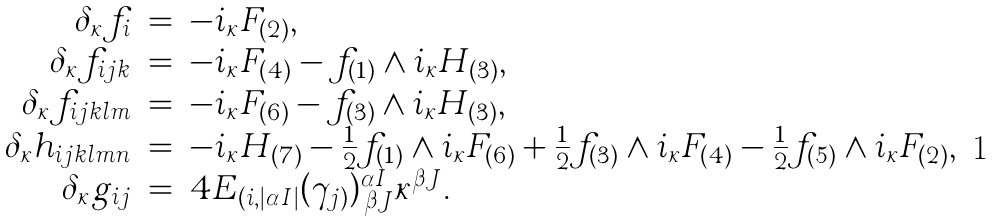Convert formula to latex. <formula><loc_0><loc_0><loc_500><loc_500>\begin{array} { r c l } \delta _ { \kappa } f _ { i } & = & - i _ { \kappa } F _ { ( 2 ) } , \\ \delta _ { \kappa } f _ { i j k } & = & - i _ { \kappa } F _ { ( 4 ) } - f _ { ( 1 ) } \wedge i _ { \kappa } H _ { ( 3 ) } , \\ \delta _ { \kappa } f _ { i j k l m } & = & - i _ { \kappa } F _ { ( 6 ) } - f _ { ( 3 ) } \wedge i _ { \kappa } H _ { ( 3 ) } , \\ \delta _ { \kappa } h _ { i j k l m n } & = & - i _ { \kappa } H _ { ( 7 ) } - \frac { 1 } { 2 } f _ { ( 1 ) } \wedge i _ { \kappa } F _ { ( 6 ) } + \frac { 1 } { 2 } f _ { ( 3 ) } \wedge i _ { \kappa } F _ { ( 4 ) } - \frac { 1 } { 2 } f _ { ( 5 ) } \wedge i _ { \kappa } F _ { ( 2 ) } , \\ \delta _ { \kappa } g _ { i j } & = & 4 E _ { ( i , | \alpha I | } ( \gamma _ { j ) } ) ^ { \alpha I } _ { \, \beta J } \kappa ^ { \beta J } . \end{array}</formula> 